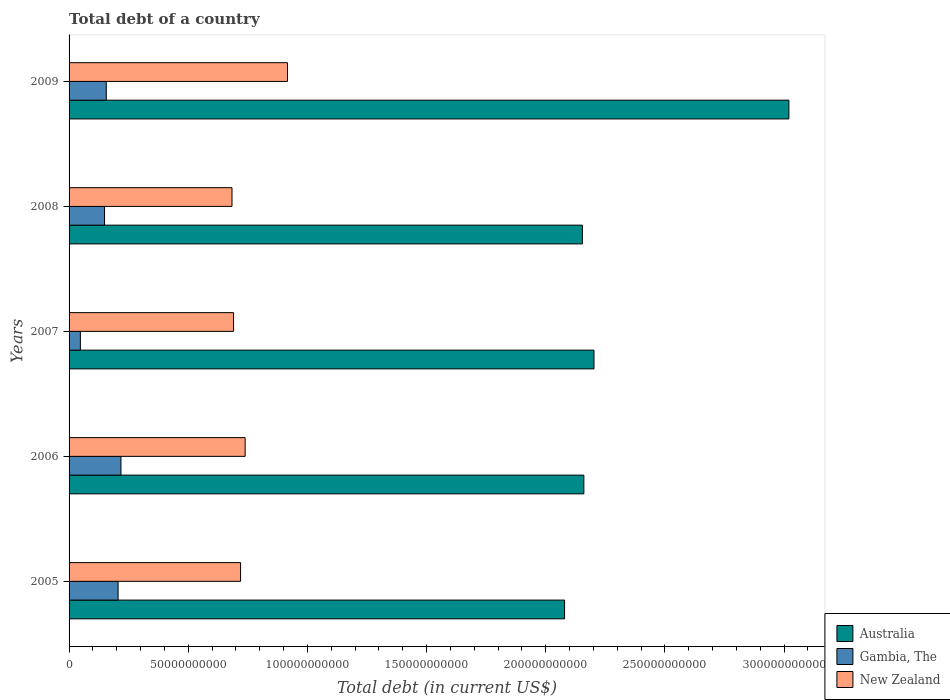Are the number of bars per tick equal to the number of legend labels?
Your answer should be compact. Yes. How many bars are there on the 1st tick from the top?
Make the answer very short. 3. What is the label of the 5th group of bars from the top?
Your answer should be very brief. 2005. In how many cases, is the number of bars for a given year not equal to the number of legend labels?
Make the answer very short. 0. What is the debt in Gambia, The in 2009?
Your response must be concise. 1.56e+1. Across all years, what is the maximum debt in New Zealand?
Provide a short and direct response. 9.17e+1. Across all years, what is the minimum debt in Gambia, The?
Provide a short and direct response. 4.74e+09. In which year was the debt in Australia maximum?
Ensure brevity in your answer.  2009. What is the total debt in New Zealand in the graph?
Your answer should be very brief. 3.75e+11. What is the difference between the debt in Gambia, The in 2007 and that in 2008?
Provide a succinct answer. -1.01e+1. What is the difference between the debt in Australia in 2006 and the debt in New Zealand in 2009?
Offer a terse response. 1.24e+11. What is the average debt in New Zealand per year?
Your response must be concise. 7.50e+1. In the year 2009, what is the difference between the debt in New Zealand and debt in Gambia, The?
Keep it short and to the point. 7.61e+1. In how many years, is the debt in Australia greater than 20000000000 US$?
Provide a succinct answer. 5. What is the ratio of the debt in Australia in 2006 to that in 2007?
Your answer should be compact. 0.98. Is the debt in Australia in 2008 less than that in 2009?
Ensure brevity in your answer.  Yes. What is the difference between the highest and the second highest debt in Gambia, The?
Your answer should be very brief. 1.20e+09. What is the difference between the highest and the lowest debt in New Zealand?
Your answer should be compact. 2.33e+1. In how many years, is the debt in New Zealand greater than the average debt in New Zealand taken over all years?
Keep it short and to the point. 1. How many bars are there?
Give a very brief answer. 15. Are all the bars in the graph horizontal?
Ensure brevity in your answer.  Yes. How many years are there in the graph?
Give a very brief answer. 5. Are the values on the major ticks of X-axis written in scientific E-notation?
Make the answer very short. No. Where does the legend appear in the graph?
Ensure brevity in your answer.  Bottom right. How many legend labels are there?
Provide a short and direct response. 3. How are the legend labels stacked?
Offer a very short reply. Vertical. What is the title of the graph?
Provide a succinct answer. Total debt of a country. Does "Sierra Leone" appear as one of the legend labels in the graph?
Your answer should be compact. No. What is the label or title of the X-axis?
Your answer should be compact. Total debt (in current US$). What is the Total debt (in current US$) of Australia in 2005?
Make the answer very short. 2.08e+11. What is the Total debt (in current US$) in Gambia, The in 2005?
Offer a very short reply. 2.06e+1. What is the Total debt (in current US$) of New Zealand in 2005?
Provide a succinct answer. 7.20e+1. What is the Total debt (in current US$) in Australia in 2006?
Provide a succinct answer. 2.16e+11. What is the Total debt (in current US$) of Gambia, The in 2006?
Your answer should be compact. 2.18e+1. What is the Total debt (in current US$) in New Zealand in 2006?
Make the answer very short. 7.39e+1. What is the Total debt (in current US$) of Australia in 2007?
Make the answer very short. 2.20e+11. What is the Total debt (in current US$) of Gambia, The in 2007?
Your answer should be compact. 4.74e+09. What is the Total debt (in current US$) of New Zealand in 2007?
Ensure brevity in your answer.  6.90e+1. What is the Total debt (in current US$) in Australia in 2008?
Give a very brief answer. 2.15e+11. What is the Total debt (in current US$) in Gambia, The in 2008?
Provide a succinct answer. 1.49e+1. What is the Total debt (in current US$) in New Zealand in 2008?
Offer a very short reply. 6.84e+1. What is the Total debt (in current US$) of Australia in 2009?
Ensure brevity in your answer.  3.02e+11. What is the Total debt (in current US$) in Gambia, The in 2009?
Your response must be concise. 1.56e+1. What is the Total debt (in current US$) in New Zealand in 2009?
Offer a terse response. 9.17e+1. Across all years, what is the maximum Total debt (in current US$) of Australia?
Give a very brief answer. 3.02e+11. Across all years, what is the maximum Total debt (in current US$) in Gambia, The?
Keep it short and to the point. 2.18e+1. Across all years, what is the maximum Total debt (in current US$) of New Zealand?
Give a very brief answer. 9.17e+1. Across all years, what is the minimum Total debt (in current US$) of Australia?
Give a very brief answer. 2.08e+11. Across all years, what is the minimum Total debt (in current US$) in Gambia, The?
Keep it short and to the point. 4.74e+09. Across all years, what is the minimum Total debt (in current US$) of New Zealand?
Provide a succinct answer. 6.84e+1. What is the total Total debt (in current US$) of Australia in the graph?
Your answer should be very brief. 1.16e+12. What is the total Total debt (in current US$) in Gambia, The in the graph?
Offer a terse response. 7.76e+1. What is the total Total debt (in current US$) of New Zealand in the graph?
Your response must be concise. 3.75e+11. What is the difference between the Total debt (in current US$) in Australia in 2005 and that in 2006?
Keep it short and to the point. -8.10e+09. What is the difference between the Total debt (in current US$) in Gambia, The in 2005 and that in 2006?
Offer a terse response. -1.20e+09. What is the difference between the Total debt (in current US$) of New Zealand in 2005 and that in 2006?
Give a very brief answer. -1.91e+09. What is the difference between the Total debt (in current US$) of Australia in 2005 and that in 2007?
Offer a terse response. -1.24e+1. What is the difference between the Total debt (in current US$) of Gambia, The in 2005 and that in 2007?
Your response must be concise. 1.58e+1. What is the difference between the Total debt (in current US$) in New Zealand in 2005 and that in 2007?
Your answer should be very brief. 2.95e+09. What is the difference between the Total debt (in current US$) in Australia in 2005 and that in 2008?
Make the answer very short. -7.49e+09. What is the difference between the Total debt (in current US$) in Gambia, The in 2005 and that in 2008?
Ensure brevity in your answer.  5.69e+09. What is the difference between the Total debt (in current US$) of New Zealand in 2005 and that in 2008?
Keep it short and to the point. 3.60e+09. What is the difference between the Total debt (in current US$) in Australia in 2005 and that in 2009?
Your answer should be compact. -9.41e+1. What is the difference between the Total debt (in current US$) of Gambia, The in 2005 and that in 2009?
Your response must be concise. 4.96e+09. What is the difference between the Total debt (in current US$) of New Zealand in 2005 and that in 2009?
Give a very brief answer. -1.97e+1. What is the difference between the Total debt (in current US$) in Australia in 2006 and that in 2007?
Ensure brevity in your answer.  -4.25e+09. What is the difference between the Total debt (in current US$) of Gambia, The in 2006 and that in 2007?
Keep it short and to the point. 1.70e+1. What is the difference between the Total debt (in current US$) in New Zealand in 2006 and that in 2007?
Offer a terse response. 4.86e+09. What is the difference between the Total debt (in current US$) in Australia in 2006 and that in 2008?
Give a very brief answer. 6.13e+08. What is the difference between the Total debt (in current US$) of Gambia, The in 2006 and that in 2008?
Ensure brevity in your answer.  6.89e+09. What is the difference between the Total debt (in current US$) in New Zealand in 2006 and that in 2008?
Ensure brevity in your answer.  5.51e+09. What is the difference between the Total debt (in current US$) in Australia in 2006 and that in 2009?
Offer a terse response. -8.60e+1. What is the difference between the Total debt (in current US$) of Gambia, The in 2006 and that in 2009?
Offer a very short reply. 6.16e+09. What is the difference between the Total debt (in current US$) in New Zealand in 2006 and that in 2009?
Offer a very short reply. -1.78e+1. What is the difference between the Total debt (in current US$) in Australia in 2007 and that in 2008?
Your answer should be compact. 4.87e+09. What is the difference between the Total debt (in current US$) of Gambia, The in 2007 and that in 2008?
Make the answer very short. -1.01e+1. What is the difference between the Total debt (in current US$) of New Zealand in 2007 and that in 2008?
Your answer should be very brief. 6.55e+08. What is the difference between the Total debt (in current US$) of Australia in 2007 and that in 2009?
Your response must be concise. -8.18e+1. What is the difference between the Total debt (in current US$) in Gambia, The in 2007 and that in 2009?
Give a very brief answer. -1.09e+1. What is the difference between the Total debt (in current US$) of New Zealand in 2007 and that in 2009?
Offer a very short reply. -2.26e+1. What is the difference between the Total debt (in current US$) of Australia in 2008 and that in 2009?
Your answer should be compact. -8.67e+1. What is the difference between the Total debt (in current US$) in Gambia, The in 2008 and that in 2009?
Offer a very short reply. -7.27e+08. What is the difference between the Total debt (in current US$) in New Zealand in 2008 and that in 2009?
Offer a terse response. -2.33e+1. What is the difference between the Total debt (in current US$) of Australia in 2005 and the Total debt (in current US$) of Gambia, The in 2006?
Provide a short and direct response. 1.86e+11. What is the difference between the Total debt (in current US$) of Australia in 2005 and the Total debt (in current US$) of New Zealand in 2006?
Ensure brevity in your answer.  1.34e+11. What is the difference between the Total debt (in current US$) of Gambia, The in 2005 and the Total debt (in current US$) of New Zealand in 2006?
Your answer should be compact. -5.33e+1. What is the difference between the Total debt (in current US$) of Australia in 2005 and the Total debt (in current US$) of Gambia, The in 2007?
Offer a very short reply. 2.03e+11. What is the difference between the Total debt (in current US$) of Australia in 2005 and the Total debt (in current US$) of New Zealand in 2007?
Make the answer very short. 1.39e+11. What is the difference between the Total debt (in current US$) in Gambia, The in 2005 and the Total debt (in current US$) in New Zealand in 2007?
Give a very brief answer. -4.85e+1. What is the difference between the Total debt (in current US$) of Australia in 2005 and the Total debt (in current US$) of Gambia, The in 2008?
Give a very brief answer. 1.93e+11. What is the difference between the Total debt (in current US$) of Australia in 2005 and the Total debt (in current US$) of New Zealand in 2008?
Provide a short and direct response. 1.40e+11. What is the difference between the Total debt (in current US$) in Gambia, The in 2005 and the Total debt (in current US$) in New Zealand in 2008?
Your answer should be very brief. -4.78e+1. What is the difference between the Total debt (in current US$) in Australia in 2005 and the Total debt (in current US$) in Gambia, The in 2009?
Offer a terse response. 1.92e+11. What is the difference between the Total debt (in current US$) in Australia in 2005 and the Total debt (in current US$) in New Zealand in 2009?
Provide a succinct answer. 1.16e+11. What is the difference between the Total debt (in current US$) of Gambia, The in 2005 and the Total debt (in current US$) of New Zealand in 2009?
Ensure brevity in your answer.  -7.11e+1. What is the difference between the Total debt (in current US$) in Australia in 2006 and the Total debt (in current US$) in Gambia, The in 2007?
Provide a succinct answer. 2.11e+11. What is the difference between the Total debt (in current US$) in Australia in 2006 and the Total debt (in current US$) in New Zealand in 2007?
Keep it short and to the point. 1.47e+11. What is the difference between the Total debt (in current US$) in Gambia, The in 2006 and the Total debt (in current US$) in New Zealand in 2007?
Your answer should be compact. -4.73e+1. What is the difference between the Total debt (in current US$) of Australia in 2006 and the Total debt (in current US$) of Gambia, The in 2008?
Keep it short and to the point. 2.01e+11. What is the difference between the Total debt (in current US$) in Australia in 2006 and the Total debt (in current US$) in New Zealand in 2008?
Make the answer very short. 1.48e+11. What is the difference between the Total debt (in current US$) of Gambia, The in 2006 and the Total debt (in current US$) of New Zealand in 2008?
Provide a succinct answer. -4.66e+1. What is the difference between the Total debt (in current US$) in Australia in 2006 and the Total debt (in current US$) in Gambia, The in 2009?
Make the answer very short. 2.00e+11. What is the difference between the Total debt (in current US$) of Australia in 2006 and the Total debt (in current US$) of New Zealand in 2009?
Make the answer very short. 1.24e+11. What is the difference between the Total debt (in current US$) of Gambia, The in 2006 and the Total debt (in current US$) of New Zealand in 2009?
Make the answer very short. -6.99e+1. What is the difference between the Total debt (in current US$) of Australia in 2007 and the Total debt (in current US$) of Gambia, The in 2008?
Offer a terse response. 2.05e+11. What is the difference between the Total debt (in current US$) of Australia in 2007 and the Total debt (in current US$) of New Zealand in 2008?
Provide a short and direct response. 1.52e+11. What is the difference between the Total debt (in current US$) of Gambia, The in 2007 and the Total debt (in current US$) of New Zealand in 2008?
Give a very brief answer. -6.36e+1. What is the difference between the Total debt (in current US$) in Australia in 2007 and the Total debt (in current US$) in Gambia, The in 2009?
Keep it short and to the point. 2.05e+11. What is the difference between the Total debt (in current US$) in Australia in 2007 and the Total debt (in current US$) in New Zealand in 2009?
Your answer should be compact. 1.29e+11. What is the difference between the Total debt (in current US$) in Gambia, The in 2007 and the Total debt (in current US$) in New Zealand in 2009?
Ensure brevity in your answer.  -8.69e+1. What is the difference between the Total debt (in current US$) in Australia in 2008 and the Total debt (in current US$) in Gambia, The in 2009?
Offer a very short reply. 2.00e+11. What is the difference between the Total debt (in current US$) in Australia in 2008 and the Total debt (in current US$) in New Zealand in 2009?
Provide a succinct answer. 1.24e+11. What is the difference between the Total debt (in current US$) in Gambia, The in 2008 and the Total debt (in current US$) in New Zealand in 2009?
Your answer should be very brief. -7.68e+1. What is the average Total debt (in current US$) of Australia per year?
Your response must be concise. 2.32e+11. What is the average Total debt (in current US$) of Gambia, The per year?
Give a very brief answer. 1.55e+1. What is the average Total debt (in current US$) in New Zealand per year?
Provide a succinct answer. 7.50e+1. In the year 2005, what is the difference between the Total debt (in current US$) in Australia and Total debt (in current US$) in Gambia, The?
Your answer should be compact. 1.87e+11. In the year 2005, what is the difference between the Total debt (in current US$) of Australia and Total debt (in current US$) of New Zealand?
Offer a terse response. 1.36e+11. In the year 2005, what is the difference between the Total debt (in current US$) of Gambia, The and Total debt (in current US$) of New Zealand?
Provide a short and direct response. -5.14e+1. In the year 2006, what is the difference between the Total debt (in current US$) in Australia and Total debt (in current US$) in Gambia, The?
Your answer should be compact. 1.94e+11. In the year 2006, what is the difference between the Total debt (in current US$) of Australia and Total debt (in current US$) of New Zealand?
Your answer should be compact. 1.42e+11. In the year 2006, what is the difference between the Total debt (in current US$) of Gambia, The and Total debt (in current US$) of New Zealand?
Your answer should be very brief. -5.21e+1. In the year 2007, what is the difference between the Total debt (in current US$) in Australia and Total debt (in current US$) in Gambia, The?
Your answer should be compact. 2.16e+11. In the year 2007, what is the difference between the Total debt (in current US$) of Australia and Total debt (in current US$) of New Zealand?
Give a very brief answer. 1.51e+11. In the year 2007, what is the difference between the Total debt (in current US$) in Gambia, The and Total debt (in current US$) in New Zealand?
Ensure brevity in your answer.  -6.43e+1. In the year 2008, what is the difference between the Total debt (in current US$) of Australia and Total debt (in current US$) of Gambia, The?
Your answer should be compact. 2.01e+11. In the year 2008, what is the difference between the Total debt (in current US$) in Australia and Total debt (in current US$) in New Zealand?
Offer a terse response. 1.47e+11. In the year 2008, what is the difference between the Total debt (in current US$) of Gambia, The and Total debt (in current US$) of New Zealand?
Make the answer very short. -5.35e+1. In the year 2009, what is the difference between the Total debt (in current US$) of Australia and Total debt (in current US$) of Gambia, The?
Your answer should be compact. 2.86e+11. In the year 2009, what is the difference between the Total debt (in current US$) of Australia and Total debt (in current US$) of New Zealand?
Ensure brevity in your answer.  2.10e+11. In the year 2009, what is the difference between the Total debt (in current US$) in Gambia, The and Total debt (in current US$) in New Zealand?
Your response must be concise. -7.61e+1. What is the ratio of the Total debt (in current US$) in Australia in 2005 to that in 2006?
Provide a short and direct response. 0.96. What is the ratio of the Total debt (in current US$) in Gambia, The in 2005 to that in 2006?
Provide a short and direct response. 0.94. What is the ratio of the Total debt (in current US$) in New Zealand in 2005 to that in 2006?
Ensure brevity in your answer.  0.97. What is the ratio of the Total debt (in current US$) of Australia in 2005 to that in 2007?
Your answer should be compact. 0.94. What is the ratio of the Total debt (in current US$) in Gambia, The in 2005 to that in 2007?
Provide a short and direct response. 4.34. What is the ratio of the Total debt (in current US$) in New Zealand in 2005 to that in 2007?
Offer a very short reply. 1.04. What is the ratio of the Total debt (in current US$) of Australia in 2005 to that in 2008?
Ensure brevity in your answer.  0.97. What is the ratio of the Total debt (in current US$) of Gambia, The in 2005 to that in 2008?
Provide a short and direct response. 1.38. What is the ratio of the Total debt (in current US$) of New Zealand in 2005 to that in 2008?
Your answer should be very brief. 1.05. What is the ratio of the Total debt (in current US$) of Australia in 2005 to that in 2009?
Ensure brevity in your answer.  0.69. What is the ratio of the Total debt (in current US$) of Gambia, The in 2005 to that in 2009?
Ensure brevity in your answer.  1.32. What is the ratio of the Total debt (in current US$) in New Zealand in 2005 to that in 2009?
Offer a very short reply. 0.79. What is the ratio of the Total debt (in current US$) of Australia in 2006 to that in 2007?
Make the answer very short. 0.98. What is the ratio of the Total debt (in current US$) in Gambia, The in 2006 to that in 2007?
Your answer should be very brief. 4.59. What is the ratio of the Total debt (in current US$) in New Zealand in 2006 to that in 2007?
Your answer should be compact. 1.07. What is the ratio of the Total debt (in current US$) in Gambia, The in 2006 to that in 2008?
Your answer should be very brief. 1.46. What is the ratio of the Total debt (in current US$) of New Zealand in 2006 to that in 2008?
Provide a short and direct response. 1.08. What is the ratio of the Total debt (in current US$) of Australia in 2006 to that in 2009?
Provide a short and direct response. 0.72. What is the ratio of the Total debt (in current US$) in Gambia, The in 2006 to that in 2009?
Keep it short and to the point. 1.39. What is the ratio of the Total debt (in current US$) of New Zealand in 2006 to that in 2009?
Provide a succinct answer. 0.81. What is the ratio of the Total debt (in current US$) in Australia in 2007 to that in 2008?
Provide a short and direct response. 1.02. What is the ratio of the Total debt (in current US$) of Gambia, The in 2007 to that in 2008?
Offer a terse response. 0.32. What is the ratio of the Total debt (in current US$) in New Zealand in 2007 to that in 2008?
Provide a succinct answer. 1.01. What is the ratio of the Total debt (in current US$) in Australia in 2007 to that in 2009?
Provide a short and direct response. 0.73. What is the ratio of the Total debt (in current US$) of Gambia, The in 2007 to that in 2009?
Give a very brief answer. 0.3. What is the ratio of the Total debt (in current US$) of New Zealand in 2007 to that in 2009?
Your answer should be very brief. 0.75. What is the ratio of the Total debt (in current US$) in Australia in 2008 to that in 2009?
Make the answer very short. 0.71. What is the ratio of the Total debt (in current US$) of Gambia, The in 2008 to that in 2009?
Provide a succinct answer. 0.95. What is the ratio of the Total debt (in current US$) of New Zealand in 2008 to that in 2009?
Your response must be concise. 0.75. What is the difference between the highest and the second highest Total debt (in current US$) in Australia?
Provide a succinct answer. 8.18e+1. What is the difference between the highest and the second highest Total debt (in current US$) in Gambia, The?
Keep it short and to the point. 1.20e+09. What is the difference between the highest and the second highest Total debt (in current US$) in New Zealand?
Ensure brevity in your answer.  1.78e+1. What is the difference between the highest and the lowest Total debt (in current US$) in Australia?
Keep it short and to the point. 9.41e+1. What is the difference between the highest and the lowest Total debt (in current US$) of Gambia, The?
Make the answer very short. 1.70e+1. What is the difference between the highest and the lowest Total debt (in current US$) in New Zealand?
Your answer should be very brief. 2.33e+1. 